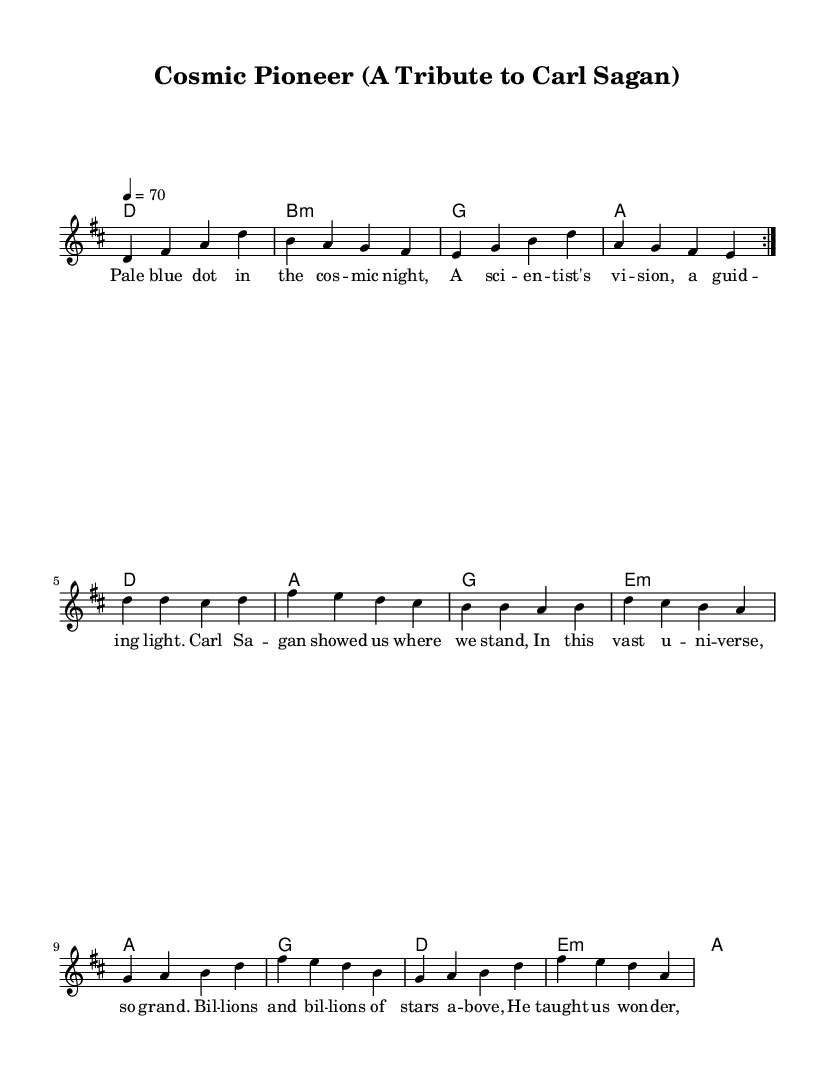What is the key signature of this music? The key signature is D major, which has two sharps (F# and C#), indicated by the placement of sharps to the left of the staff.
Answer: D major What is the time signature of this music? The time signature shown is 4/4, which is indicated at the beginning of the staff, meaning there are four beats per measure, and the quarter note gets one beat.
Answer: 4/4 What is the tempo marking for this piece? The tempo marking is stated at the beginning as 70 beats per minute, indicated by the tempo directive which states "4 = 70".
Answer: 70 How many measures are in the first verse? By counting the individual segments separated by vertical lines (bars) in the melody for the first verse, there are eight measures.
Answer: 8 What is the primary theme of the lyrics? The lyrics celebrate Carl Sagan's contributions to science and the cosmos. The lyrics discuss his vision and inspiration regarding the universe and exploration.
Answer: Carl Sagan Which note is the highest in the melody? The highest note in the melody is D, which occurs in the first measure of the second section of the melody, as indicated by the upward placement of the note on the staff.
Answer: D What kind of song structure is present in this piece? The structure follows a verse-chorus format where the verse introduces the theme and is followed by the chorus that reinforces the message, evident by the distinct lyrical sections.
Answer: Verse-chorus 